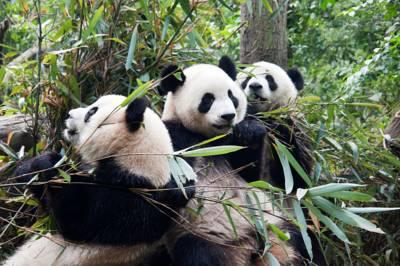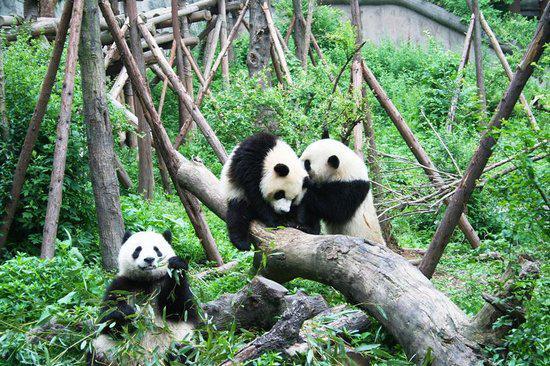The first image is the image on the left, the second image is the image on the right. Analyze the images presented: Is the assertion "The left image contains exactly one panda." valid? Answer yes or no. No. The first image is the image on the left, the second image is the image on the right. Considering the images on both sides, is "A panda is climbing a wooden limb in one image, and pandas are munching on bamboo leaves in the other image." valid? Answer yes or no. Yes. 